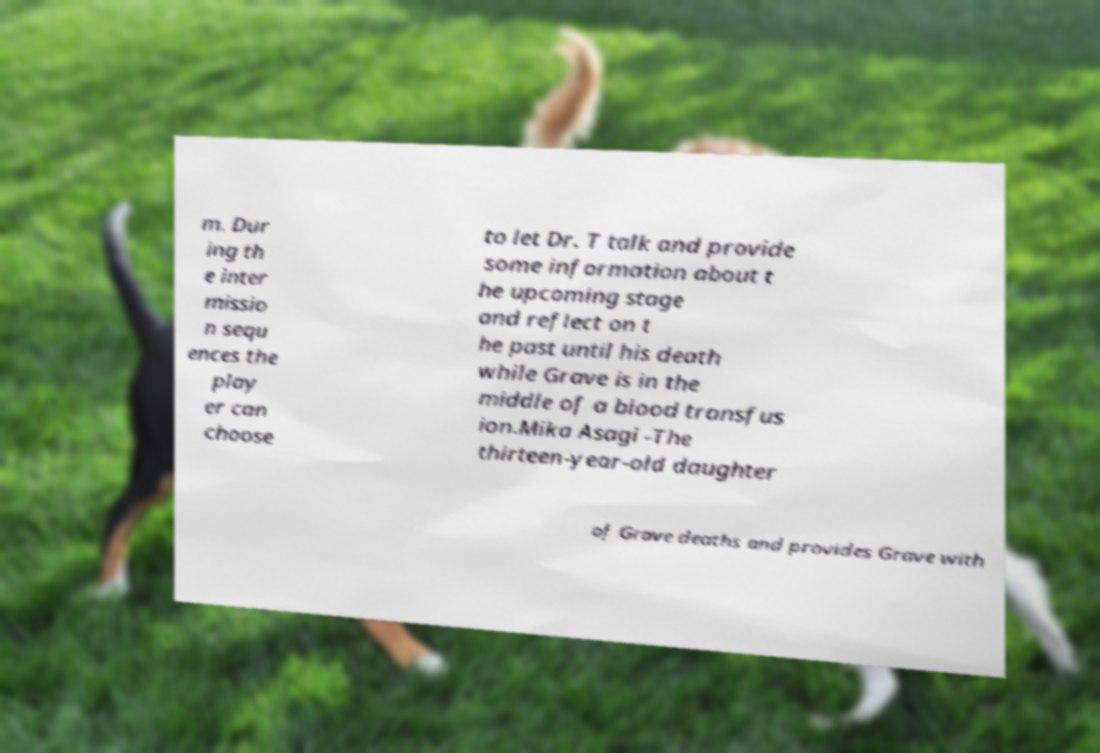Please read and relay the text visible in this image. What does it say? m. Dur ing th e inter missio n sequ ences the play er can choose to let Dr. T talk and provide some information about t he upcoming stage and reflect on t he past until his death while Grave is in the middle of a blood transfus ion.Mika Asagi -The thirteen-year-old daughter of Grave deaths and provides Grave with 